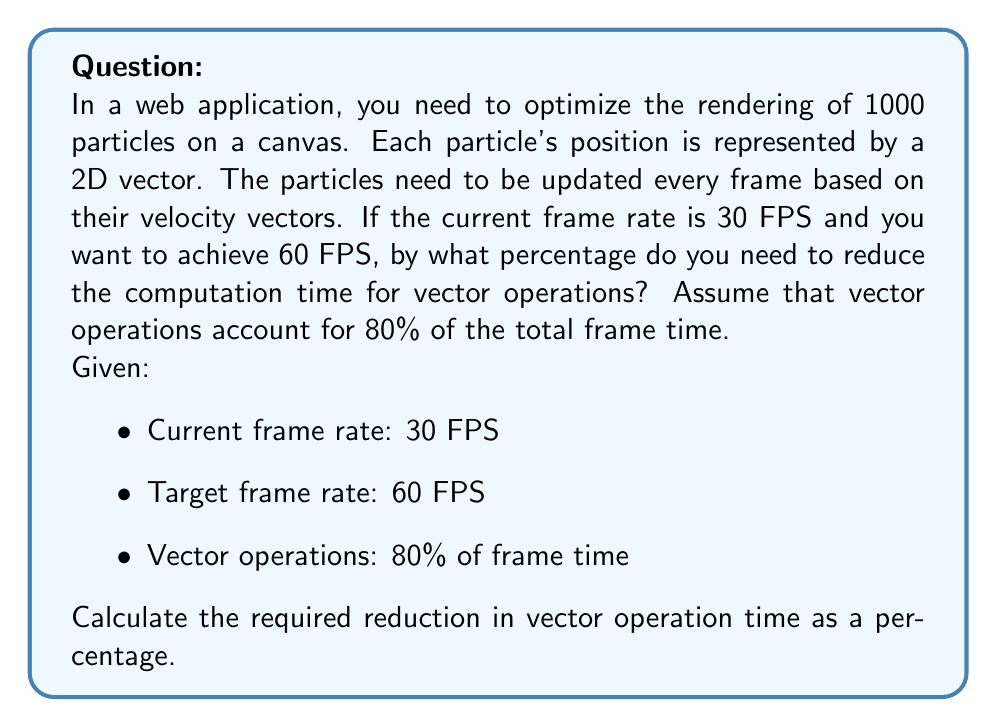Solve this math problem. Let's approach this step-by-step:

1) First, calculate the current frame time:
   $$\text{Current frame time} = \frac{1}{\text{Current FPS}} = \frac{1}{30} \approx 0.0333 \text{ seconds}$$

2) Calculate the target frame time:
   $$\text{Target frame time} = \frac{1}{\text{Target FPS}} = \frac{1}{60} \approx 0.0167 \text{ seconds}$$

3) Calculate the current time spent on vector operations:
   $$\text{Current vector time} = 0.80 \times 0.0333 \approx 0.0267 \text{ seconds}$$

4) Calculate the remaining time for non-vector operations:
   $$\text{Non-vector time} = 0.20 \times 0.0333 \approx 0.0067 \text{ seconds}$$

5) Calculate the available time for vector operations in the target frame:
   $$\text{Available vector time} = 0.0167 - 0.0067 = 0.0100 \text{ seconds}$$

6) Calculate the reduction in vector operation time:
   $$\text{Reduction} = 0.0267 - 0.0100 = 0.0167 \text{ seconds}$$

7) Calculate the percentage reduction:
   $$\text{Percentage reduction} = \frac{0.0167}{0.0267} \times 100\% \approx 62.5\%$$

Therefore, you need to reduce the computation time for vector operations by approximately 62.5% to achieve the target frame rate.
Answer: 62.5% 